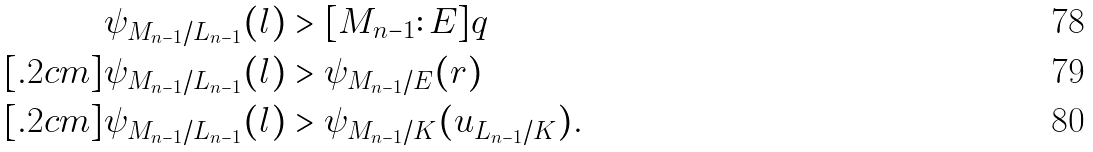Convert formula to latex. <formula><loc_0><loc_0><loc_500><loc_500>\psi _ { M _ { n - 1 } / L _ { n - 1 } } ( l ) & > [ M _ { n - 1 } \colon E ] q \\ [ . 2 c m ] \psi _ { M _ { n - 1 } / L _ { n - 1 } } ( l ) & > \psi _ { M _ { n - 1 } / E } ( r ) \\ [ . 2 c m ] \psi _ { M _ { n - 1 } / L _ { n - 1 } } ( l ) & > \psi _ { M _ { n - 1 } / K } ( u _ { L _ { n - 1 } / K } ) .</formula> 